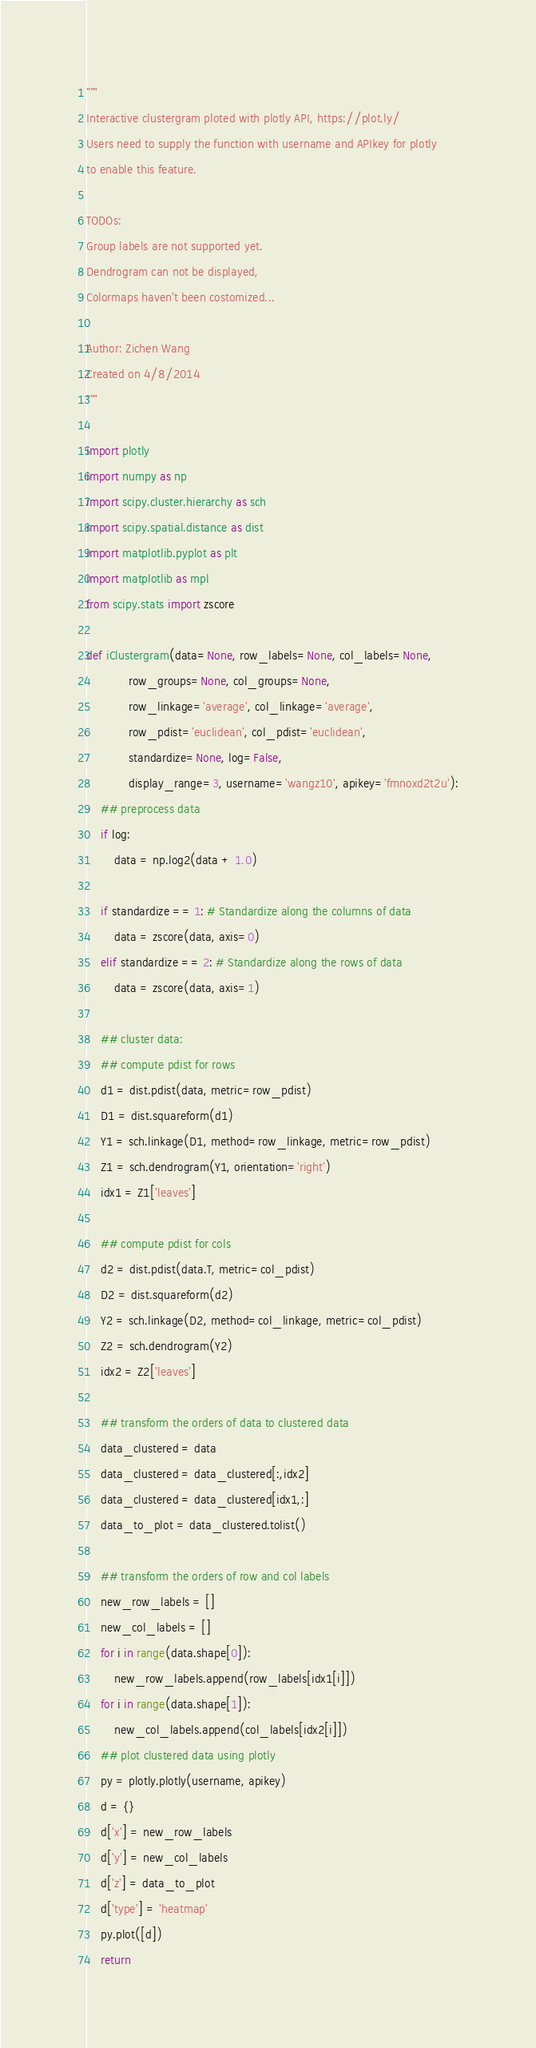Convert code to text. <code><loc_0><loc_0><loc_500><loc_500><_Python_>"""
Interactive clustergram ploted with plotly API, https://plot.ly/
Users need to supply the function with username and APIkey for plotly
to enable this feature. 

TODOs:
Group labels are not supported yet.
Dendrogram can not be displayed, 
Colormaps haven't been costomized...

Author: Zichen Wang
Created on 4/8/2014
"""

import plotly
import numpy as np
import scipy.cluster.hierarchy as sch
import scipy.spatial.distance as dist
import matplotlib.pyplot as plt
import matplotlib as mpl
from scipy.stats import zscore

def iClustergram(data=None, row_labels=None, col_labels=None,
			row_groups=None, col_groups=None,
			row_linkage='average', col_linkage='average', 
			row_pdist='euclidean', col_pdist='euclidean',
			standardize=None, log=False, 
			display_range=3, username='wangz10', apikey='fmnoxd2t2u'):
	## preprocess data
	if log:
		data = np.log2(data + 1.0)

	if standardize == 1: # Standardize along the columns of data
		data = zscore(data, axis=0)
	elif standardize == 2: # Standardize along the rows of data
		data = zscore(data, axis=1)

	## cluster data:
	## compute pdist for rows
	d1 = dist.pdist(data, metric=row_pdist)
	D1 = dist.squareform(d1)
	Y1 = sch.linkage(D1, method=row_linkage, metric=row_pdist)
	Z1 = sch.dendrogram(Y1, orientation='right')
	idx1 = Z1['leaves']

	## compute pdist for cols
	d2 = dist.pdist(data.T, metric=col_pdist)
	D2 = dist.squareform(d2)
	Y2 = sch.linkage(D2, method=col_linkage, metric=col_pdist)
	Z2 = sch.dendrogram(Y2)
	idx2 = Z2['leaves']

	## transform the orders of data to clustered data
	data_clustered = data
	data_clustered = data_clustered[:,idx2]
	data_clustered = data_clustered[idx1,:]
	data_to_plot = data_clustered.tolist()

	## transform the orders of row and col labels
	new_row_labels = []
	new_col_labels = []
	for i in range(data.shape[0]):
		new_row_labels.append(row_labels[idx1[i]])
	for i in range(data.shape[1]):
		new_col_labels.append(col_labels[idx2[i]])
	## plot clustered data using plotly
	py = plotly.plotly(username, apikey)
	d = {}
	d['x'] = new_row_labels
	d['y'] = new_col_labels
	d['z'] = data_to_plot
	d['type'] = 'heatmap'
	py.plot([d])
	return
</code> 